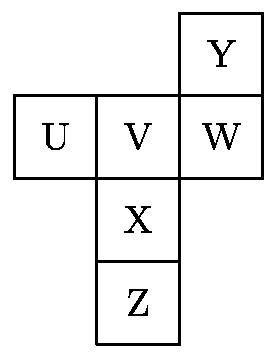If this diagram were representing a real object, such as a box, which labels could represent the top and bottom of the box in its typical use? Typically, 'Y' could represent the top of the box, given its central position and typical visual perspective, while 'Z' could logically be seen as the bottom if the box is standing in an upright position. 